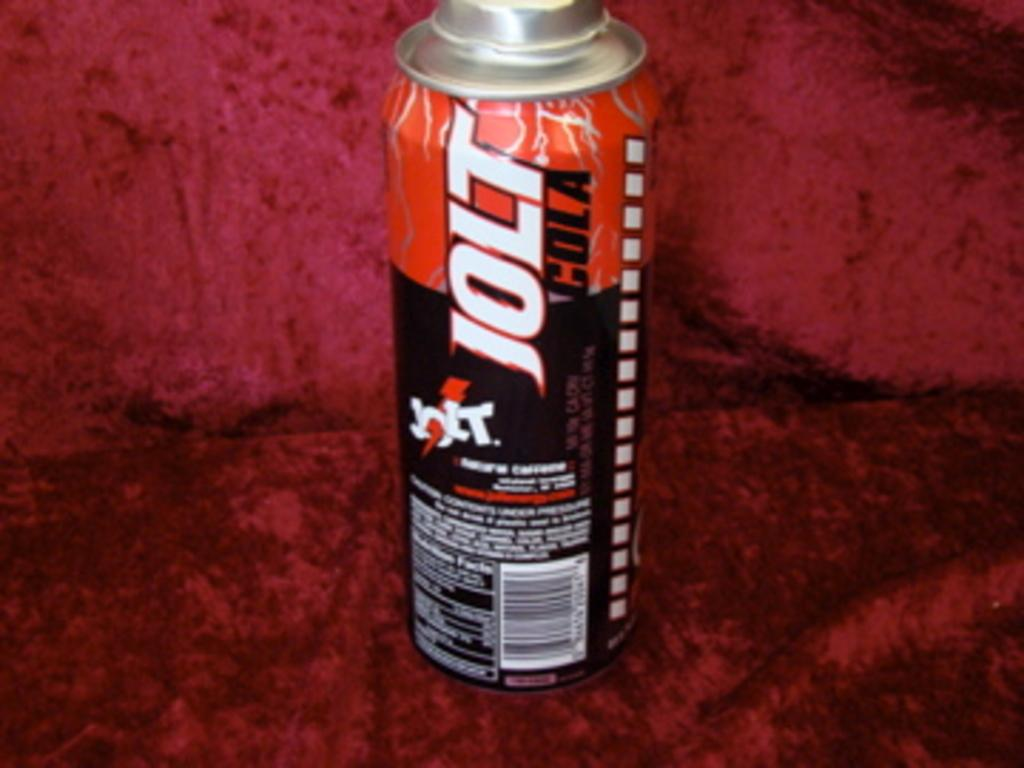<image>
Write a terse but informative summary of the picture. A can of black and red Jolt Cola. 